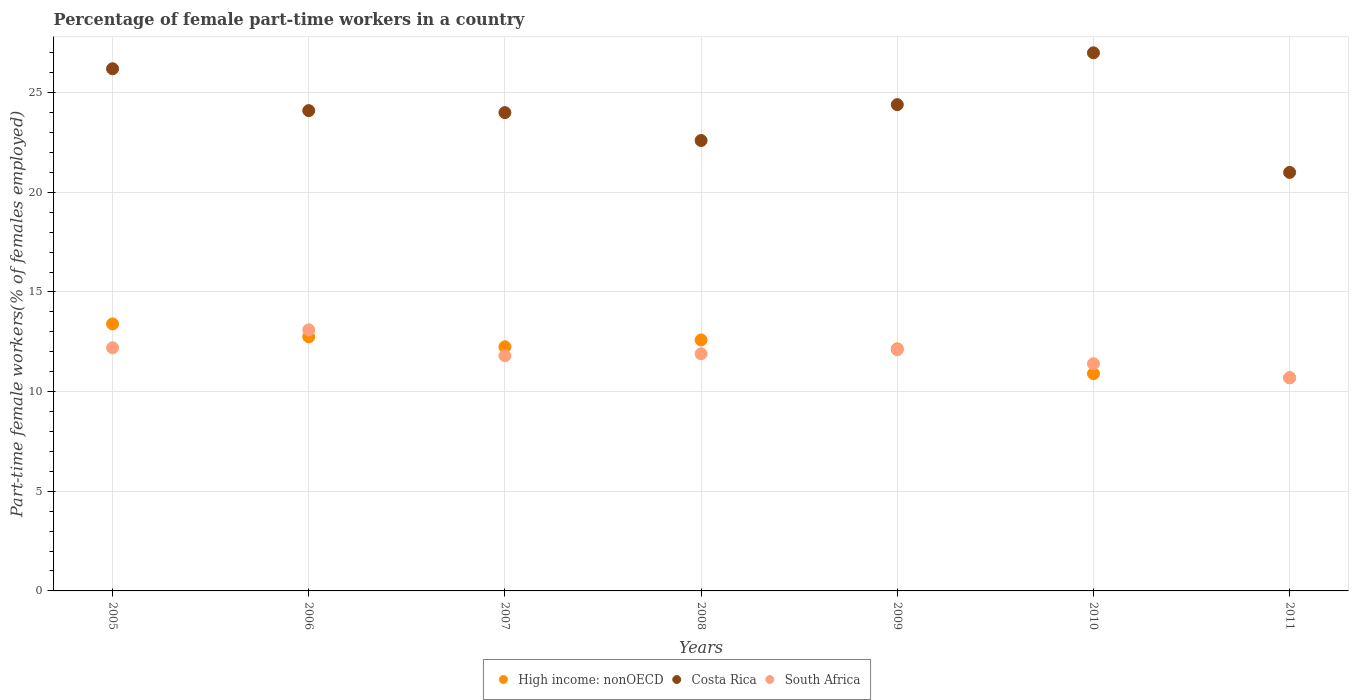Across all years, what is the maximum percentage of female part-time workers in High income: nonOECD?
Your answer should be compact. 13.4. Across all years, what is the minimum percentage of female part-time workers in High income: nonOECD?
Keep it short and to the point. 10.69. In which year was the percentage of female part-time workers in South Africa maximum?
Ensure brevity in your answer.  2006. What is the total percentage of female part-time workers in South Africa in the graph?
Offer a terse response. 83.2. What is the difference between the percentage of female part-time workers in Costa Rica in 2007 and that in 2008?
Ensure brevity in your answer.  1.4. What is the difference between the percentage of female part-time workers in Costa Rica in 2008 and the percentage of female part-time workers in High income: nonOECD in 2010?
Your response must be concise. 11.7. What is the average percentage of female part-time workers in South Africa per year?
Offer a terse response. 11.89. In the year 2008, what is the difference between the percentage of female part-time workers in High income: nonOECD and percentage of female part-time workers in South Africa?
Give a very brief answer. 0.69. What is the ratio of the percentage of female part-time workers in South Africa in 2007 to that in 2011?
Your answer should be very brief. 1.1. Is the percentage of female part-time workers in Costa Rica in 2005 less than that in 2007?
Ensure brevity in your answer.  No. What is the difference between the highest and the second highest percentage of female part-time workers in High income: nonOECD?
Your answer should be very brief. 0.64. What is the difference between the highest and the lowest percentage of female part-time workers in High income: nonOECD?
Ensure brevity in your answer.  2.7. Is the sum of the percentage of female part-time workers in Costa Rica in 2007 and 2008 greater than the maximum percentage of female part-time workers in High income: nonOECD across all years?
Your response must be concise. Yes. Does the percentage of female part-time workers in Costa Rica monotonically increase over the years?
Your response must be concise. No. Is the percentage of female part-time workers in High income: nonOECD strictly greater than the percentage of female part-time workers in South Africa over the years?
Offer a terse response. No. Is the percentage of female part-time workers in High income: nonOECD strictly less than the percentage of female part-time workers in Costa Rica over the years?
Your answer should be very brief. Yes. How many years are there in the graph?
Make the answer very short. 7. What is the difference between two consecutive major ticks on the Y-axis?
Keep it short and to the point. 5. Does the graph contain any zero values?
Keep it short and to the point. No. Where does the legend appear in the graph?
Your answer should be compact. Bottom center. How are the legend labels stacked?
Ensure brevity in your answer.  Horizontal. What is the title of the graph?
Offer a terse response. Percentage of female part-time workers in a country. What is the label or title of the X-axis?
Provide a short and direct response. Years. What is the label or title of the Y-axis?
Your response must be concise. Part-time female workers(% of females employed). What is the Part-time female workers(% of females employed) in High income: nonOECD in 2005?
Provide a short and direct response. 13.4. What is the Part-time female workers(% of females employed) in Costa Rica in 2005?
Provide a succinct answer. 26.2. What is the Part-time female workers(% of females employed) in South Africa in 2005?
Give a very brief answer. 12.2. What is the Part-time female workers(% of females employed) of High income: nonOECD in 2006?
Your response must be concise. 12.75. What is the Part-time female workers(% of females employed) in Costa Rica in 2006?
Your answer should be compact. 24.1. What is the Part-time female workers(% of females employed) of South Africa in 2006?
Ensure brevity in your answer.  13.1. What is the Part-time female workers(% of females employed) in High income: nonOECD in 2007?
Offer a very short reply. 12.25. What is the Part-time female workers(% of females employed) of Costa Rica in 2007?
Give a very brief answer. 24. What is the Part-time female workers(% of females employed) in South Africa in 2007?
Offer a terse response. 11.8. What is the Part-time female workers(% of females employed) in High income: nonOECD in 2008?
Offer a very short reply. 12.59. What is the Part-time female workers(% of females employed) in Costa Rica in 2008?
Offer a very short reply. 22.6. What is the Part-time female workers(% of females employed) in South Africa in 2008?
Your answer should be very brief. 11.9. What is the Part-time female workers(% of females employed) in High income: nonOECD in 2009?
Provide a short and direct response. 12.14. What is the Part-time female workers(% of females employed) in Costa Rica in 2009?
Your answer should be compact. 24.4. What is the Part-time female workers(% of females employed) in South Africa in 2009?
Offer a very short reply. 12.1. What is the Part-time female workers(% of females employed) of High income: nonOECD in 2010?
Keep it short and to the point. 10.9. What is the Part-time female workers(% of females employed) in Costa Rica in 2010?
Ensure brevity in your answer.  27. What is the Part-time female workers(% of females employed) of South Africa in 2010?
Offer a very short reply. 11.4. What is the Part-time female workers(% of females employed) in High income: nonOECD in 2011?
Keep it short and to the point. 10.69. What is the Part-time female workers(% of females employed) in South Africa in 2011?
Your response must be concise. 10.7. Across all years, what is the maximum Part-time female workers(% of females employed) in High income: nonOECD?
Make the answer very short. 13.4. Across all years, what is the maximum Part-time female workers(% of females employed) of South Africa?
Make the answer very short. 13.1. Across all years, what is the minimum Part-time female workers(% of females employed) of High income: nonOECD?
Provide a succinct answer. 10.69. Across all years, what is the minimum Part-time female workers(% of females employed) of Costa Rica?
Make the answer very short. 21. Across all years, what is the minimum Part-time female workers(% of females employed) of South Africa?
Provide a succinct answer. 10.7. What is the total Part-time female workers(% of females employed) of High income: nonOECD in the graph?
Provide a short and direct response. 84.73. What is the total Part-time female workers(% of females employed) in Costa Rica in the graph?
Ensure brevity in your answer.  169.3. What is the total Part-time female workers(% of females employed) in South Africa in the graph?
Your answer should be very brief. 83.2. What is the difference between the Part-time female workers(% of females employed) in High income: nonOECD in 2005 and that in 2006?
Your answer should be very brief. 0.64. What is the difference between the Part-time female workers(% of females employed) in South Africa in 2005 and that in 2006?
Offer a terse response. -0.9. What is the difference between the Part-time female workers(% of females employed) of High income: nonOECD in 2005 and that in 2007?
Make the answer very short. 1.15. What is the difference between the Part-time female workers(% of females employed) in Costa Rica in 2005 and that in 2007?
Ensure brevity in your answer.  2.2. What is the difference between the Part-time female workers(% of females employed) in High income: nonOECD in 2005 and that in 2008?
Offer a terse response. 0.8. What is the difference between the Part-time female workers(% of females employed) of South Africa in 2005 and that in 2008?
Your answer should be compact. 0.3. What is the difference between the Part-time female workers(% of females employed) in High income: nonOECD in 2005 and that in 2009?
Make the answer very short. 1.25. What is the difference between the Part-time female workers(% of females employed) of South Africa in 2005 and that in 2009?
Your answer should be very brief. 0.1. What is the difference between the Part-time female workers(% of females employed) of High income: nonOECD in 2005 and that in 2010?
Provide a short and direct response. 2.49. What is the difference between the Part-time female workers(% of females employed) of Costa Rica in 2005 and that in 2010?
Your answer should be compact. -0.8. What is the difference between the Part-time female workers(% of females employed) in High income: nonOECD in 2005 and that in 2011?
Provide a succinct answer. 2.7. What is the difference between the Part-time female workers(% of females employed) of Costa Rica in 2005 and that in 2011?
Keep it short and to the point. 5.2. What is the difference between the Part-time female workers(% of females employed) of High income: nonOECD in 2006 and that in 2007?
Your response must be concise. 0.5. What is the difference between the Part-time female workers(% of females employed) in South Africa in 2006 and that in 2007?
Make the answer very short. 1.3. What is the difference between the Part-time female workers(% of females employed) in High income: nonOECD in 2006 and that in 2008?
Offer a very short reply. 0.16. What is the difference between the Part-time female workers(% of females employed) of Costa Rica in 2006 and that in 2008?
Your response must be concise. 1.5. What is the difference between the Part-time female workers(% of females employed) of High income: nonOECD in 2006 and that in 2009?
Ensure brevity in your answer.  0.61. What is the difference between the Part-time female workers(% of females employed) in Costa Rica in 2006 and that in 2009?
Keep it short and to the point. -0.3. What is the difference between the Part-time female workers(% of females employed) of South Africa in 2006 and that in 2009?
Make the answer very short. 1. What is the difference between the Part-time female workers(% of females employed) in High income: nonOECD in 2006 and that in 2010?
Ensure brevity in your answer.  1.85. What is the difference between the Part-time female workers(% of females employed) in South Africa in 2006 and that in 2010?
Keep it short and to the point. 1.7. What is the difference between the Part-time female workers(% of females employed) of High income: nonOECD in 2006 and that in 2011?
Provide a short and direct response. 2.06. What is the difference between the Part-time female workers(% of females employed) in Costa Rica in 2006 and that in 2011?
Your response must be concise. 3.1. What is the difference between the Part-time female workers(% of females employed) of South Africa in 2006 and that in 2011?
Provide a succinct answer. 2.4. What is the difference between the Part-time female workers(% of females employed) in High income: nonOECD in 2007 and that in 2008?
Provide a succinct answer. -0.34. What is the difference between the Part-time female workers(% of females employed) in High income: nonOECD in 2007 and that in 2009?
Give a very brief answer. 0.11. What is the difference between the Part-time female workers(% of females employed) in High income: nonOECD in 2007 and that in 2010?
Ensure brevity in your answer.  1.35. What is the difference between the Part-time female workers(% of females employed) of High income: nonOECD in 2007 and that in 2011?
Your answer should be very brief. 1.55. What is the difference between the Part-time female workers(% of females employed) in South Africa in 2007 and that in 2011?
Offer a very short reply. 1.1. What is the difference between the Part-time female workers(% of females employed) of High income: nonOECD in 2008 and that in 2009?
Give a very brief answer. 0.45. What is the difference between the Part-time female workers(% of females employed) in High income: nonOECD in 2008 and that in 2010?
Give a very brief answer. 1.69. What is the difference between the Part-time female workers(% of females employed) in Costa Rica in 2008 and that in 2010?
Keep it short and to the point. -4.4. What is the difference between the Part-time female workers(% of females employed) in High income: nonOECD in 2008 and that in 2011?
Provide a succinct answer. 1.9. What is the difference between the Part-time female workers(% of females employed) of South Africa in 2008 and that in 2011?
Ensure brevity in your answer.  1.2. What is the difference between the Part-time female workers(% of females employed) of High income: nonOECD in 2009 and that in 2010?
Your response must be concise. 1.24. What is the difference between the Part-time female workers(% of females employed) in Costa Rica in 2009 and that in 2010?
Your response must be concise. -2.6. What is the difference between the Part-time female workers(% of females employed) in High income: nonOECD in 2009 and that in 2011?
Your answer should be compact. 1.45. What is the difference between the Part-time female workers(% of females employed) in South Africa in 2009 and that in 2011?
Give a very brief answer. 1.4. What is the difference between the Part-time female workers(% of females employed) of High income: nonOECD in 2010 and that in 2011?
Ensure brevity in your answer.  0.21. What is the difference between the Part-time female workers(% of females employed) of Costa Rica in 2010 and that in 2011?
Ensure brevity in your answer.  6. What is the difference between the Part-time female workers(% of females employed) of South Africa in 2010 and that in 2011?
Ensure brevity in your answer.  0.7. What is the difference between the Part-time female workers(% of females employed) of High income: nonOECD in 2005 and the Part-time female workers(% of females employed) of Costa Rica in 2006?
Offer a very short reply. -10.7. What is the difference between the Part-time female workers(% of females employed) in High income: nonOECD in 2005 and the Part-time female workers(% of females employed) in South Africa in 2006?
Your answer should be compact. 0.3. What is the difference between the Part-time female workers(% of females employed) in High income: nonOECD in 2005 and the Part-time female workers(% of females employed) in Costa Rica in 2007?
Provide a succinct answer. -10.6. What is the difference between the Part-time female workers(% of females employed) in High income: nonOECD in 2005 and the Part-time female workers(% of females employed) in South Africa in 2007?
Ensure brevity in your answer.  1.6. What is the difference between the Part-time female workers(% of females employed) of Costa Rica in 2005 and the Part-time female workers(% of females employed) of South Africa in 2007?
Ensure brevity in your answer.  14.4. What is the difference between the Part-time female workers(% of females employed) of High income: nonOECD in 2005 and the Part-time female workers(% of females employed) of Costa Rica in 2008?
Provide a short and direct response. -9.2. What is the difference between the Part-time female workers(% of females employed) of High income: nonOECD in 2005 and the Part-time female workers(% of females employed) of South Africa in 2008?
Offer a terse response. 1.5. What is the difference between the Part-time female workers(% of females employed) in High income: nonOECD in 2005 and the Part-time female workers(% of females employed) in Costa Rica in 2009?
Provide a short and direct response. -11. What is the difference between the Part-time female workers(% of females employed) in High income: nonOECD in 2005 and the Part-time female workers(% of females employed) in South Africa in 2009?
Your answer should be very brief. 1.3. What is the difference between the Part-time female workers(% of females employed) in High income: nonOECD in 2005 and the Part-time female workers(% of females employed) in Costa Rica in 2010?
Your answer should be very brief. -13.6. What is the difference between the Part-time female workers(% of females employed) in High income: nonOECD in 2005 and the Part-time female workers(% of females employed) in South Africa in 2010?
Offer a terse response. 2. What is the difference between the Part-time female workers(% of females employed) in Costa Rica in 2005 and the Part-time female workers(% of females employed) in South Africa in 2010?
Keep it short and to the point. 14.8. What is the difference between the Part-time female workers(% of females employed) in High income: nonOECD in 2005 and the Part-time female workers(% of females employed) in Costa Rica in 2011?
Your response must be concise. -7.6. What is the difference between the Part-time female workers(% of females employed) of High income: nonOECD in 2005 and the Part-time female workers(% of females employed) of South Africa in 2011?
Ensure brevity in your answer.  2.7. What is the difference between the Part-time female workers(% of females employed) of High income: nonOECD in 2006 and the Part-time female workers(% of females employed) of Costa Rica in 2007?
Your response must be concise. -11.25. What is the difference between the Part-time female workers(% of females employed) of High income: nonOECD in 2006 and the Part-time female workers(% of females employed) of South Africa in 2007?
Give a very brief answer. 0.95. What is the difference between the Part-time female workers(% of females employed) of High income: nonOECD in 2006 and the Part-time female workers(% of females employed) of Costa Rica in 2008?
Offer a very short reply. -9.85. What is the difference between the Part-time female workers(% of females employed) of High income: nonOECD in 2006 and the Part-time female workers(% of females employed) of South Africa in 2008?
Give a very brief answer. 0.85. What is the difference between the Part-time female workers(% of females employed) in High income: nonOECD in 2006 and the Part-time female workers(% of females employed) in Costa Rica in 2009?
Offer a very short reply. -11.65. What is the difference between the Part-time female workers(% of females employed) of High income: nonOECD in 2006 and the Part-time female workers(% of females employed) of South Africa in 2009?
Make the answer very short. 0.65. What is the difference between the Part-time female workers(% of females employed) in High income: nonOECD in 2006 and the Part-time female workers(% of females employed) in Costa Rica in 2010?
Provide a succinct answer. -14.25. What is the difference between the Part-time female workers(% of females employed) of High income: nonOECD in 2006 and the Part-time female workers(% of females employed) of South Africa in 2010?
Provide a short and direct response. 1.35. What is the difference between the Part-time female workers(% of females employed) in Costa Rica in 2006 and the Part-time female workers(% of females employed) in South Africa in 2010?
Your answer should be compact. 12.7. What is the difference between the Part-time female workers(% of females employed) of High income: nonOECD in 2006 and the Part-time female workers(% of females employed) of Costa Rica in 2011?
Keep it short and to the point. -8.25. What is the difference between the Part-time female workers(% of females employed) of High income: nonOECD in 2006 and the Part-time female workers(% of females employed) of South Africa in 2011?
Give a very brief answer. 2.05. What is the difference between the Part-time female workers(% of females employed) of High income: nonOECD in 2007 and the Part-time female workers(% of females employed) of Costa Rica in 2008?
Your response must be concise. -10.35. What is the difference between the Part-time female workers(% of females employed) in High income: nonOECD in 2007 and the Part-time female workers(% of females employed) in South Africa in 2008?
Offer a very short reply. 0.35. What is the difference between the Part-time female workers(% of females employed) in High income: nonOECD in 2007 and the Part-time female workers(% of females employed) in Costa Rica in 2009?
Provide a succinct answer. -12.15. What is the difference between the Part-time female workers(% of females employed) in High income: nonOECD in 2007 and the Part-time female workers(% of females employed) in South Africa in 2009?
Your response must be concise. 0.15. What is the difference between the Part-time female workers(% of females employed) of High income: nonOECD in 2007 and the Part-time female workers(% of females employed) of Costa Rica in 2010?
Offer a very short reply. -14.75. What is the difference between the Part-time female workers(% of females employed) of High income: nonOECD in 2007 and the Part-time female workers(% of females employed) of South Africa in 2010?
Offer a very short reply. 0.85. What is the difference between the Part-time female workers(% of females employed) of Costa Rica in 2007 and the Part-time female workers(% of females employed) of South Africa in 2010?
Your response must be concise. 12.6. What is the difference between the Part-time female workers(% of females employed) in High income: nonOECD in 2007 and the Part-time female workers(% of females employed) in Costa Rica in 2011?
Keep it short and to the point. -8.75. What is the difference between the Part-time female workers(% of females employed) in High income: nonOECD in 2007 and the Part-time female workers(% of females employed) in South Africa in 2011?
Your answer should be compact. 1.55. What is the difference between the Part-time female workers(% of females employed) in High income: nonOECD in 2008 and the Part-time female workers(% of females employed) in Costa Rica in 2009?
Make the answer very short. -11.81. What is the difference between the Part-time female workers(% of females employed) of High income: nonOECD in 2008 and the Part-time female workers(% of females employed) of South Africa in 2009?
Your answer should be very brief. 0.49. What is the difference between the Part-time female workers(% of females employed) in High income: nonOECD in 2008 and the Part-time female workers(% of females employed) in Costa Rica in 2010?
Offer a very short reply. -14.41. What is the difference between the Part-time female workers(% of females employed) of High income: nonOECD in 2008 and the Part-time female workers(% of females employed) of South Africa in 2010?
Offer a very short reply. 1.19. What is the difference between the Part-time female workers(% of females employed) of Costa Rica in 2008 and the Part-time female workers(% of females employed) of South Africa in 2010?
Your answer should be very brief. 11.2. What is the difference between the Part-time female workers(% of females employed) of High income: nonOECD in 2008 and the Part-time female workers(% of females employed) of Costa Rica in 2011?
Ensure brevity in your answer.  -8.41. What is the difference between the Part-time female workers(% of females employed) in High income: nonOECD in 2008 and the Part-time female workers(% of females employed) in South Africa in 2011?
Provide a short and direct response. 1.89. What is the difference between the Part-time female workers(% of females employed) of High income: nonOECD in 2009 and the Part-time female workers(% of females employed) of Costa Rica in 2010?
Provide a short and direct response. -14.86. What is the difference between the Part-time female workers(% of females employed) in High income: nonOECD in 2009 and the Part-time female workers(% of females employed) in South Africa in 2010?
Provide a succinct answer. 0.74. What is the difference between the Part-time female workers(% of females employed) of Costa Rica in 2009 and the Part-time female workers(% of females employed) of South Africa in 2010?
Give a very brief answer. 13. What is the difference between the Part-time female workers(% of females employed) of High income: nonOECD in 2009 and the Part-time female workers(% of females employed) of Costa Rica in 2011?
Your answer should be compact. -8.86. What is the difference between the Part-time female workers(% of females employed) in High income: nonOECD in 2009 and the Part-time female workers(% of females employed) in South Africa in 2011?
Offer a terse response. 1.44. What is the difference between the Part-time female workers(% of females employed) in Costa Rica in 2009 and the Part-time female workers(% of females employed) in South Africa in 2011?
Give a very brief answer. 13.7. What is the difference between the Part-time female workers(% of females employed) of High income: nonOECD in 2010 and the Part-time female workers(% of females employed) of Costa Rica in 2011?
Provide a succinct answer. -10.1. What is the difference between the Part-time female workers(% of females employed) in High income: nonOECD in 2010 and the Part-time female workers(% of females employed) in South Africa in 2011?
Offer a very short reply. 0.2. What is the difference between the Part-time female workers(% of females employed) of Costa Rica in 2010 and the Part-time female workers(% of females employed) of South Africa in 2011?
Make the answer very short. 16.3. What is the average Part-time female workers(% of females employed) in High income: nonOECD per year?
Provide a succinct answer. 12.1. What is the average Part-time female workers(% of females employed) of Costa Rica per year?
Keep it short and to the point. 24.19. What is the average Part-time female workers(% of females employed) of South Africa per year?
Offer a very short reply. 11.89. In the year 2005, what is the difference between the Part-time female workers(% of females employed) of High income: nonOECD and Part-time female workers(% of females employed) of Costa Rica?
Provide a succinct answer. -12.8. In the year 2005, what is the difference between the Part-time female workers(% of females employed) of High income: nonOECD and Part-time female workers(% of females employed) of South Africa?
Your answer should be compact. 1.2. In the year 2006, what is the difference between the Part-time female workers(% of females employed) in High income: nonOECD and Part-time female workers(% of females employed) in Costa Rica?
Keep it short and to the point. -11.35. In the year 2006, what is the difference between the Part-time female workers(% of females employed) in High income: nonOECD and Part-time female workers(% of females employed) in South Africa?
Offer a very short reply. -0.35. In the year 2007, what is the difference between the Part-time female workers(% of females employed) in High income: nonOECD and Part-time female workers(% of females employed) in Costa Rica?
Make the answer very short. -11.75. In the year 2007, what is the difference between the Part-time female workers(% of females employed) of High income: nonOECD and Part-time female workers(% of females employed) of South Africa?
Provide a short and direct response. 0.45. In the year 2007, what is the difference between the Part-time female workers(% of females employed) in Costa Rica and Part-time female workers(% of females employed) in South Africa?
Keep it short and to the point. 12.2. In the year 2008, what is the difference between the Part-time female workers(% of females employed) in High income: nonOECD and Part-time female workers(% of females employed) in Costa Rica?
Make the answer very short. -10.01. In the year 2008, what is the difference between the Part-time female workers(% of females employed) of High income: nonOECD and Part-time female workers(% of females employed) of South Africa?
Ensure brevity in your answer.  0.69. In the year 2009, what is the difference between the Part-time female workers(% of females employed) in High income: nonOECD and Part-time female workers(% of females employed) in Costa Rica?
Offer a terse response. -12.26. In the year 2009, what is the difference between the Part-time female workers(% of females employed) in High income: nonOECD and Part-time female workers(% of females employed) in South Africa?
Your response must be concise. 0.04. In the year 2010, what is the difference between the Part-time female workers(% of females employed) of High income: nonOECD and Part-time female workers(% of females employed) of Costa Rica?
Make the answer very short. -16.1. In the year 2010, what is the difference between the Part-time female workers(% of females employed) in High income: nonOECD and Part-time female workers(% of females employed) in South Africa?
Keep it short and to the point. -0.5. In the year 2010, what is the difference between the Part-time female workers(% of females employed) of Costa Rica and Part-time female workers(% of females employed) of South Africa?
Offer a very short reply. 15.6. In the year 2011, what is the difference between the Part-time female workers(% of females employed) in High income: nonOECD and Part-time female workers(% of females employed) in Costa Rica?
Provide a short and direct response. -10.31. In the year 2011, what is the difference between the Part-time female workers(% of females employed) of High income: nonOECD and Part-time female workers(% of females employed) of South Africa?
Make the answer very short. -0.01. In the year 2011, what is the difference between the Part-time female workers(% of females employed) of Costa Rica and Part-time female workers(% of females employed) of South Africa?
Your answer should be compact. 10.3. What is the ratio of the Part-time female workers(% of females employed) of High income: nonOECD in 2005 to that in 2006?
Your response must be concise. 1.05. What is the ratio of the Part-time female workers(% of females employed) in Costa Rica in 2005 to that in 2006?
Your answer should be very brief. 1.09. What is the ratio of the Part-time female workers(% of females employed) of South Africa in 2005 to that in 2006?
Give a very brief answer. 0.93. What is the ratio of the Part-time female workers(% of females employed) in High income: nonOECD in 2005 to that in 2007?
Provide a succinct answer. 1.09. What is the ratio of the Part-time female workers(% of females employed) of Costa Rica in 2005 to that in 2007?
Your answer should be compact. 1.09. What is the ratio of the Part-time female workers(% of females employed) of South Africa in 2005 to that in 2007?
Keep it short and to the point. 1.03. What is the ratio of the Part-time female workers(% of females employed) of High income: nonOECD in 2005 to that in 2008?
Give a very brief answer. 1.06. What is the ratio of the Part-time female workers(% of females employed) in Costa Rica in 2005 to that in 2008?
Offer a very short reply. 1.16. What is the ratio of the Part-time female workers(% of females employed) of South Africa in 2005 to that in 2008?
Your answer should be compact. 1.03. What is the ratio of the Part-time female workers(% of females employed) in High income: nonOECD in 2005 to that in 2009?
Your answer should be very brief. 1.1. What is the ratio of the Part-time female workers(% of females employed) of Costa Rica in 2005 to that in 2009?
Give a very brief answer. 1.07. What is the ratio of the Part-time female workers(% of females employed) of South Africa in 2005 to that in 2009?
Provide a short and direct response. 1.01. What is the ratio of the Part-time female workers(% of females employed) in High income: nonOECD in 2005 to that in 2010?
Offer a terse response. 1.23. What is the ratio of the Part-time female workers(% of females employed) in Costa Rica in 2005 to that in 2010?
Your answer should be compact. 0.97. What is the ratio of the Part-time female workers(% of females employed) of South Africa in 2005 to that in 2010?
Provide a succinct answer. 1.07. What is the ratio of the Part-time female workers(% of females employed) of High income: nonOECD in 2005 to that in 2011?
Ensure brevity in your answer.  1.25. What is the ratio of the Part-time female workers(% of females employed) in Costa Rica in 2005 to that in 2011?
Your response must be concise. 1.25. What is the ratio of the Part-time female workers(% of females employed) of South Africa in 2005 to that in 2011?
Your answer should be very brief. 1.14. What is the ratio of the Part-time female workers(% of females employed) of High income: nonOECD in 2006 to that in 2007?
Make the answer very short. 1.04. What is the ratio of the Part-time female workers(% of females employed) of Costa Rica in 2006 to that in 2007?
Your answer should be very brief. 1. What is the ratio of the Part-time female workers(% of females employed) in South Africa in 2006 to that in 2007?
Provide a short and direct response. 1.11. What is the ratio of the Part-time female workers(% of females employed) in High income: nonOECD in 2006 to that in 2008?
Provide a succinct answer. 1.01. What is the ratio of the Part-time female workers(% of females employed) of Costa Rica in 2006 to that in 2008?
Offer a terse response. 1.07. What is the ratio of the Part-time female workers(% of females employed) in South Africa in 2006 to that in 2008?
Your answer should be very brief. 1.1. What is the ratio of the Part-time female workers(% of females employed) of High income: nonOECD in 2006 to that in 2009?
Give a very brief answer. 1.05. What is the ratio of the Part-time female workers(% of females employed) of South Africa in 2006 to that in 2009?
Keep it short and to the point. 1.08. What is the ratio of the Part-time female workers(% of females employed) in High income: nonOECD in 2006 to that in 2010?
Your answer should be very brief. 1.17. What is the ratio of the Part-time female workers(% of females employed) in Costa Rica in 2006 to that in 2010?
Provide a succinct answer. 0.89. What is the ratio of the Part-time female workers(% of females employed) of South Africa in 2006 to that in 2010?
Offer a very short reply. 1.15. What is the ratio of the Part-time female workers(% of females employed) of High income: nonOECD in 2006 to that in 2011?
Keep it short and to the point. 1.19. What is the ratio of the Part-time female workers(% of females employed) in Costa Rica in 2006 to that in 2011?
Your answer should be very brief. 1.15. What is the ratio of the Part-time female workers(% of females employed) in South Africa in 2006 to that in 2011?
Keep it short and to the point. 1.22. What is the ratio of the Part-time female workers(% of females employed) in High income: nonOECD in 2007 to that in 2008?
Your answer should be very brief. 0.97. What is the ratio of the Part-time female workers(% of females employed) in Costa Rica in 2007 to that in 2008?
Make the answer very short. 1.06. What is the ratio of the Part-time female workers(% of females employed) in South Africa in 2007 to that in 2008?
Make the answer very short. 0.99. What is the ratio of the Part-time female workers(% of females employed) in High income: nonOECD in 2007 to that in 2009?
Your response must be concise. 1.01. What is the ratio of the Part-time female workers(% of females employed) of Costa Rica in 2007 to that in 2009?
Keep it short and to the point. 0.98. What is the ratio of the Part-time female workers(% of females employed) of South Africa in 2007 to that in 2009?
Your answer should be very brief. 0.98. What is the ratio of the Part-time female workers(% of females employed) of High income: nonOECD in 2007 to that in 2010?
Your response must be concise. 1.12. What is the ratio of the Part-time female workers(% of females employed) in Costa Rica in 2007 to that in 2010?
Provide a succinct answer. 0.89. What is the ratio of the Part-time female workers(% of females employed) of South Africa in 2007 to that in 2010?
Provide a short and direct response. 1.04. What is the ratio of the Part-time female workers(% of females employed) of High income: nonOECD in 2007 to that in 2011?
Provide a short and direct response. 1.15. What is the ratio of the Part-time female workers(% of females employed) of South Africa in 2007 to that in 2011?
Provide a succinct answer. 1.1. What is the ratio of the Part-time female workers(% of females employed) of High income: nonOECD in 2008 to that in 2009?
Keep it short and to the point. 1.04. What is the ratio of the Part-time female workers(% of females employed) in Costa Rica in 2008 to that in 2009?
Provide a succinct answer. 0.93. What is the ratio of the Part-time female workers(% of females employed) in South Africa in 2008 to that in 2009?
Ensure brevity in your answer.  0.98. What is the ratio of the Part-time female workers(% of females employed) of High income: nonOECD in 2008 to that in 2010?
Ensure brevity in your answer.  1.16. What is the ratio of the Part-time female workers(% of females employed) of Costa Rica in 2008 to that in 2010?
Your answer should be very brief. 0.84. What is the ratio of the Part-time female workers(% of females employed) of South Africa in 2008 to that in 2010?
Offer a terse response. 1.04. What is the ratio of the Part-time female workers(% of females employed) of High income: nonOECD in 2008 to that in 2011?
Offer a terse response. 1.18. What is the ratio of the Part-time female workers(% of females employed) in Costa Rica in 2008 to that in 2011?
Make the answer very short. 1.08. What is the ratio of the Part-time female workers(% of females employed) in South Africa in 2008 to that in 2011?
Ensure brevity in your answer.  1.11. What is the ratio of the Part-time female workers(% of females employed) in High income: nonOECD in 2009 to that in 2010?
Your answer should be very brief. 1.11. What is the ratio of the Part-time female workers(% of females employed) of Costa Rica in 2009 to that in 2010?
Your answer should be very brief. 0.9. What is the ratio of the Part-time female workers(% of females employed) in South Africa in 2009 to that in 2010?
Offer a very short reply. 1.06. What is the ratio of the Part-time female workers(% of females employed) of High income: nonOECD in 2009 to that in 2011?
Give a very brief answer. 1.14. What is the ratio of the Part-time female workers(% of females employed) in Costa Rica in 2009 to that in 2011?
Your response must be concise. 1.16. What is the ratio of the Part-time female workers(% of females employed) of South Africa in 2009 to that in 2011?
Provide a short and direct response. 1.13. What is the ratio of the Part-time female workers(% of females employed) of High income: nonOECD in 2010 to that in 2011?
Give a very brief answer. 1.02. What is the ratio of the Part-time female workers(% of females employed) in Costa Rica in 2010 to that in 2011?
Your answer should be very brief. 1.29. What is the ratio of the Part-time female workers(% of females employed) in South Africa in 2010 to that in 2011?
Offer a terse response. 1.07. What is the difference between the highest and the second highest Part-time female workers(% of females employed) in High income: nonOECD?
Ensure brevity in your answer.  0.64. What is the difference between the highest and the second highest Part-time female workers(% of females employed) of South Africa?
Provide a short and direct response. 0.9. What is the difference between the highest and the lowest Part-time female workers(% of females employed) in High income: nonOECD?
Provide a succinct answer. 2.7. What is the difference between the highest and the lowest Part-time female workers(% of females employed) of Costa Rica?
Provide a succinct answer. 6. 